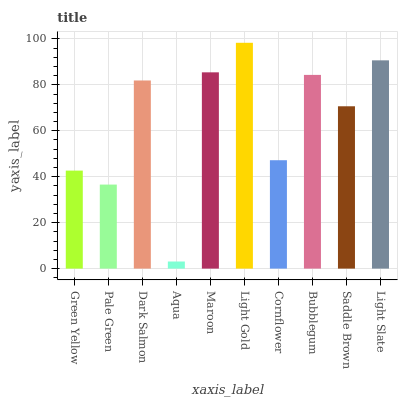Is Pale Green the minimum?
Answer yes or no. No. Is Pale Green the maximum?
Answer yes or no. No. Is Green Yellow greater than Pale Green?
Answer yes or no. Yes. Is Pale Green less than Green Yellow?
Answer yes or no. Yes. Is Pale Green greater than Green Yellow?
Answer yes or no. No. Is Green Yellow less than Pale Green?
Answer yes or no. No. Is Dark Salmon the high median?
Answer yes or no. Yes. Is Saddle Brown the low median?
Answer yes or no. Yes. Is Maroon the high median?
Answer yes or no. No. Is Bubblegum the low median?
Answer yes or no. No. 